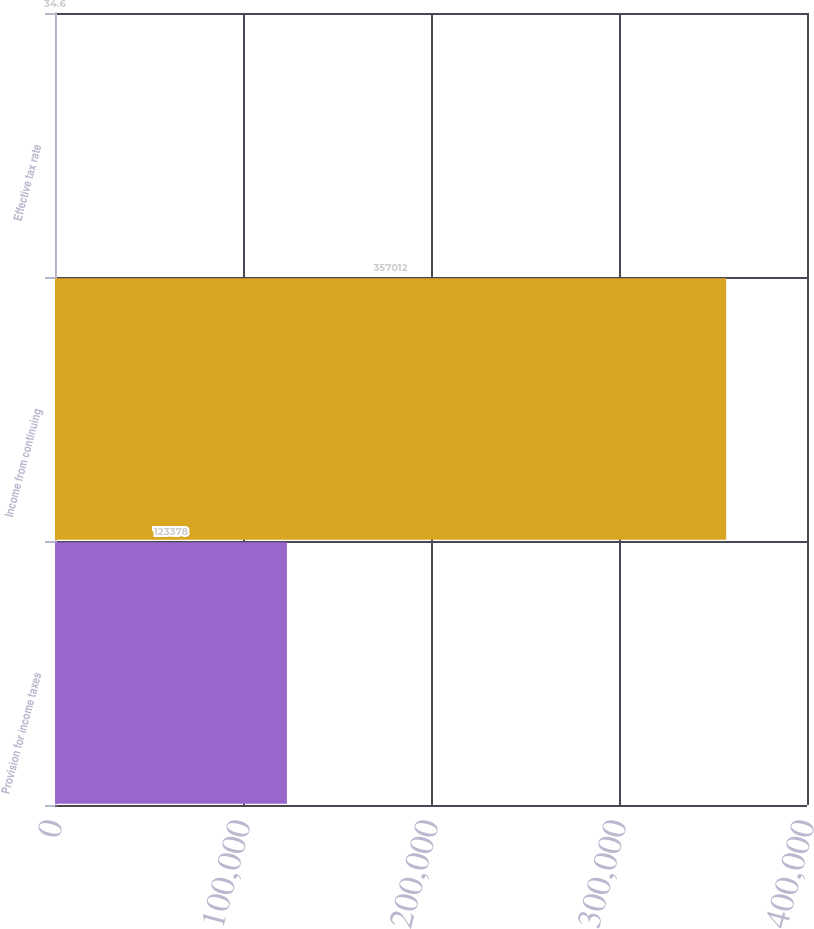Convert chart to OTSL. <chart><loc_0><loc_0><loc_500><loc_500><bar_chart><fcel>Provision for income taxes<fcel>Income from continuing<fcel>Effective tax rate<nl><fcel>123378<fcel>357012<fcel>34.6<nl></chart> 